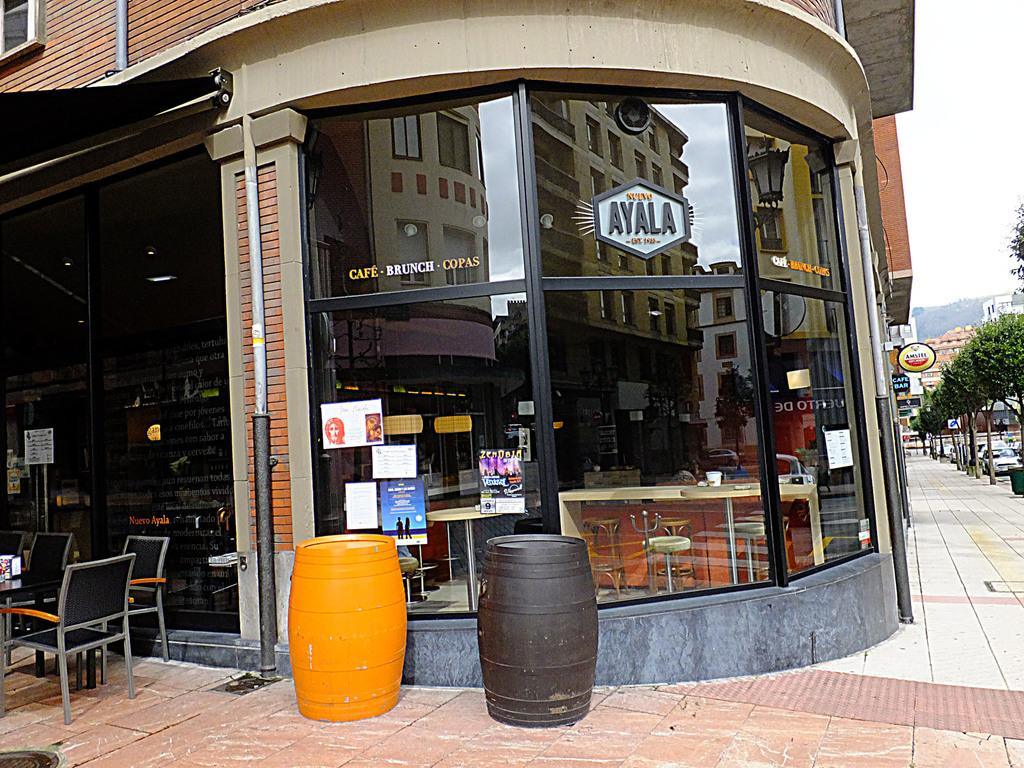What type of structure is present in the image? There is a building in the image. What can be found near the building? There is a dustbin, chairs, a poster, and a footpath in the image. What type of vegetation is visible in the image? There are trees in the image. What is visible in the background of the image? The sky is visible in the image. What other object can be seen in the image? There is a pipe in the image. What type of butter is being used in the meeting depicted in the image? There is no meeting or butter present in the image. What type of change is being discussed in the meeting depicted in the image? There is no meeting present in the image, so it is not possible to determine what type of change might be discussed. 